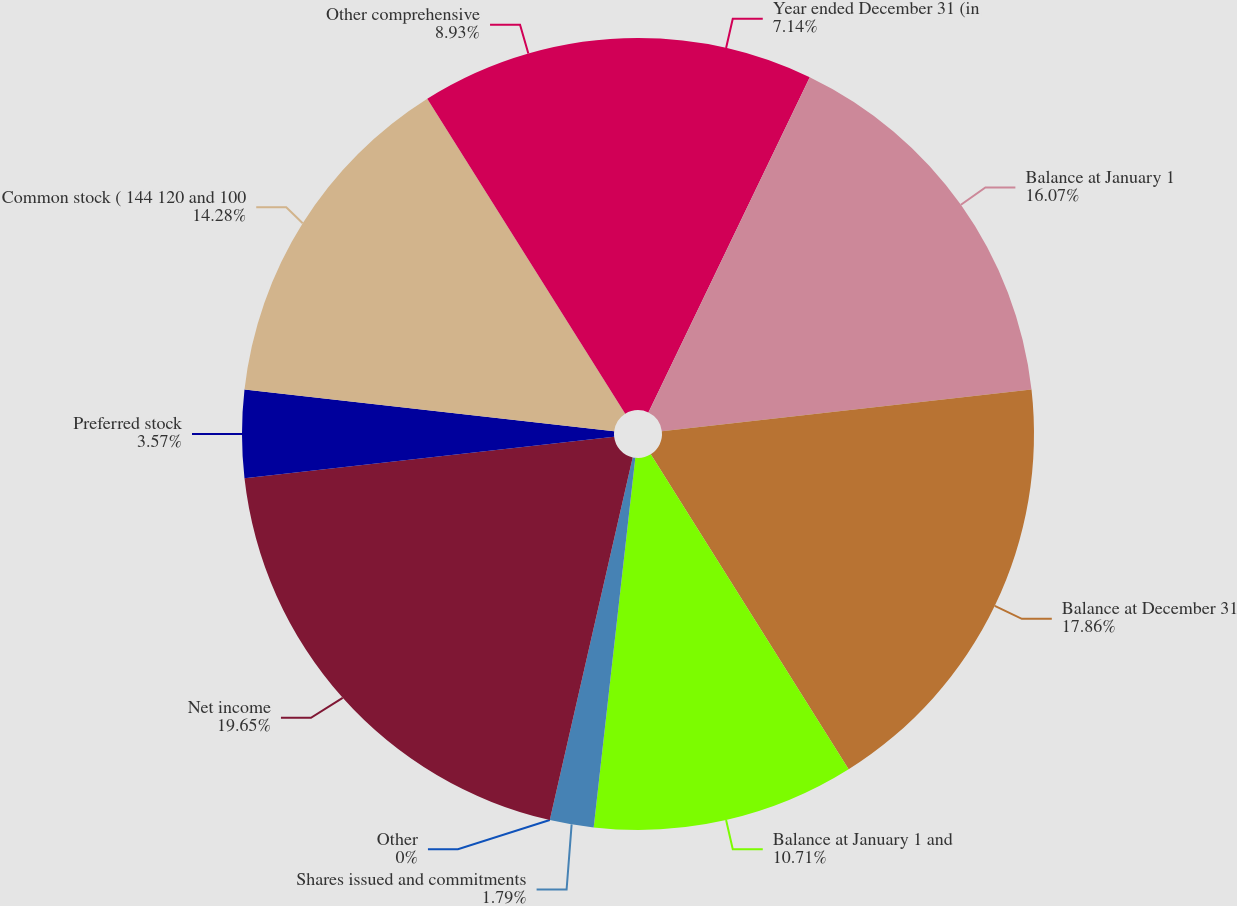Convert chart to OTSL. <chart><loc_0><loc_0><loc_500><loc_500><pie_chart><fcel>Year ended December 31 (in<fcel>Balance at January 1<fcel>Balance at December 31<fcel>Balance at January 1 and<fcel>Shares issued and commitments<fcel>Other<fcel>Net income<fcel>Preferred stock<fcel>Common stock ( 144 120 and 100<fcel>Other comprehensive<nl><fcel>7.14%<fcel>16.07%<fcel>17.86%<fcel>10.71%<fcel>1.79%<fcel>0.0%<fcel>19.64%<fcel>3.57%<fcel>14.28%<fcel>8.93%<nl></chart> 